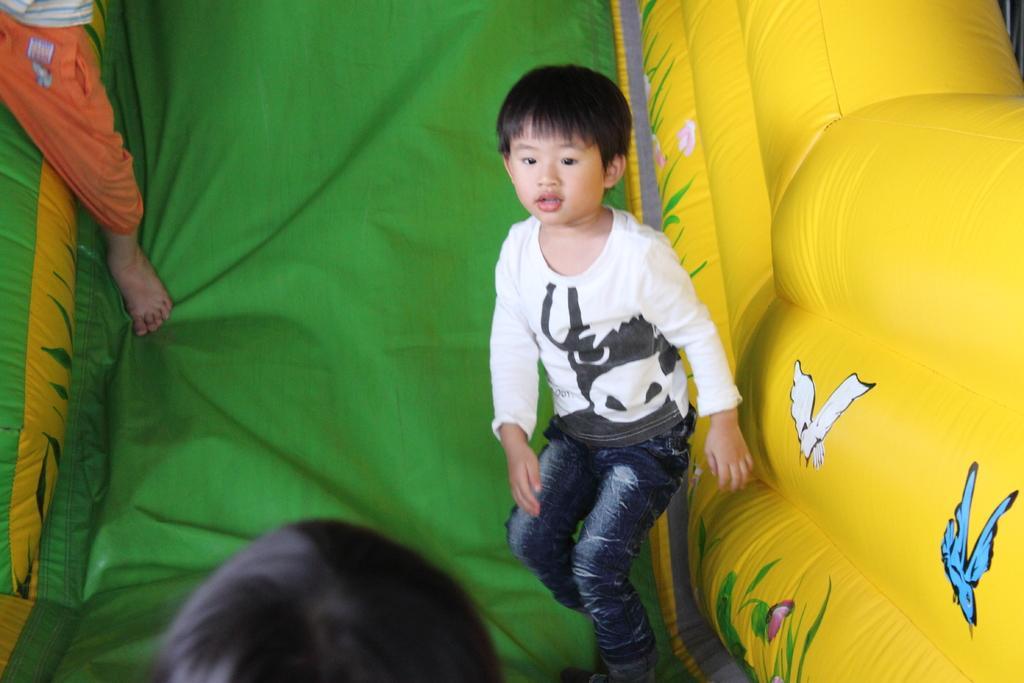In one or two sentences, can you explain what this image depicts? In this picture we can see three people, balloon slide and on this slide we can see birds, plants and a butterfly. 